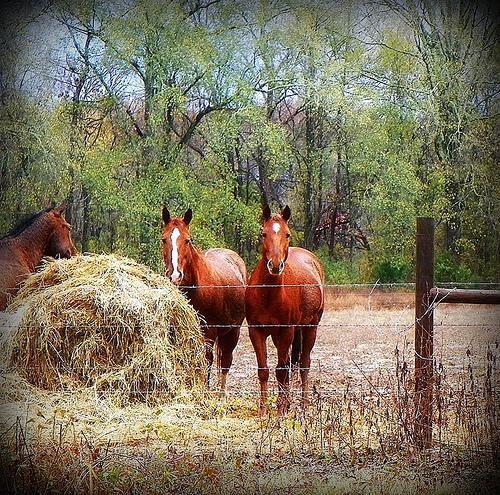How many horses are there?
Give a very brief answer. 3. 